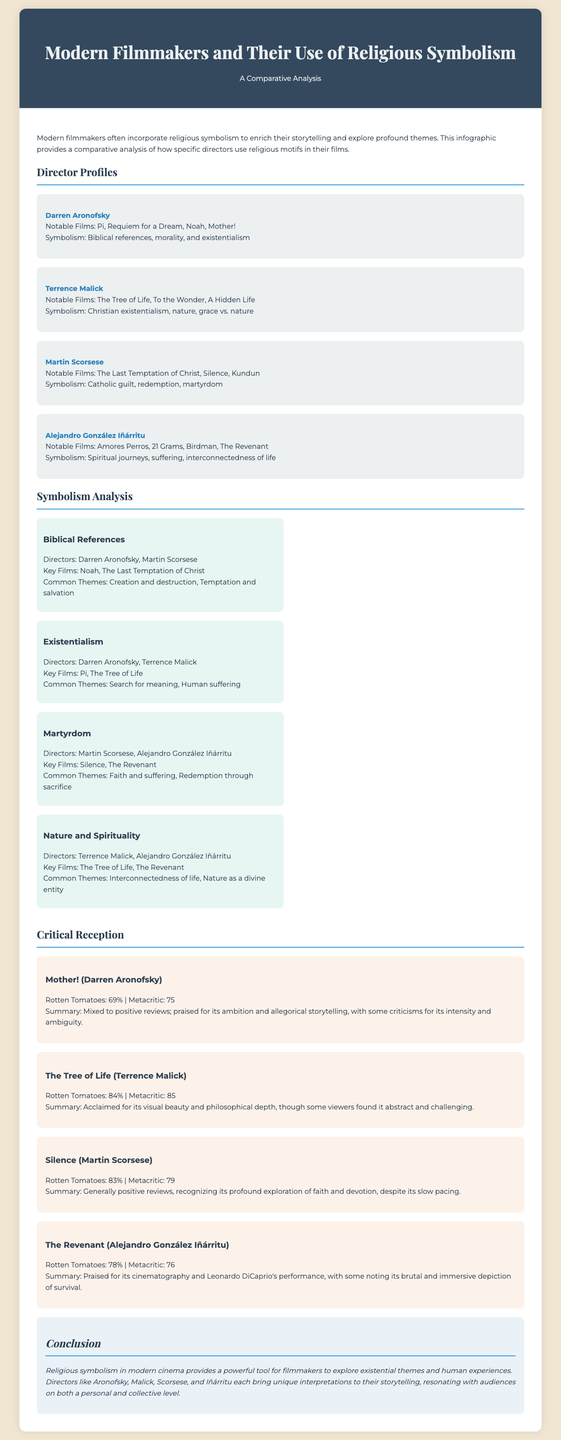what is the title of the document? The title of the document is provided in the header section, stating the main focus of the infographic.
Answer: Modern Filmmakers and Their Use of Religious Symbolism who directed the film "Silence"? The director's name is mentioned in the director profiles section where notable films are listed.
Answer: Martin Scorsese which film is noted for incorporating spiritual journeys? The key films listed under directors often highlight the thematic elements of their storytelling.
Answer: Amores Perros what is the Rotten Tomatoes score for "The Tree of Life"? The critical reception section provides specific ratings for each film, including percentages.
Answer: 84% which two directors are associated with Nature and Spirituality? The symbolism analysis section indicates directors associated with specific themes in their notable works.
Answer: Terrence Malick, Alejandro González Iñárritu what common theme is associated with martyrdom in the document? The symbolism analysis details common themes outlined for each group of directors and their films.
Answer: Faith and suffering how many notable films are listed for Darren Aronofsky? The director profile typically includes the number of notable films next to the director's name.
Answer: Four which director's work is primarily associated with existentialism? The symbolism analysis specifies the directors linked to various thematic elements, including existentialism.
Answer: Darren Aronofsky what is the overall conclusion about religious symbolism in modern cinema? The conclusion encapsulates the main findings regarding the use of religious symbolism by modern filmmakers.
Answer: A powerful tool for filmmakers to explore existential themes 